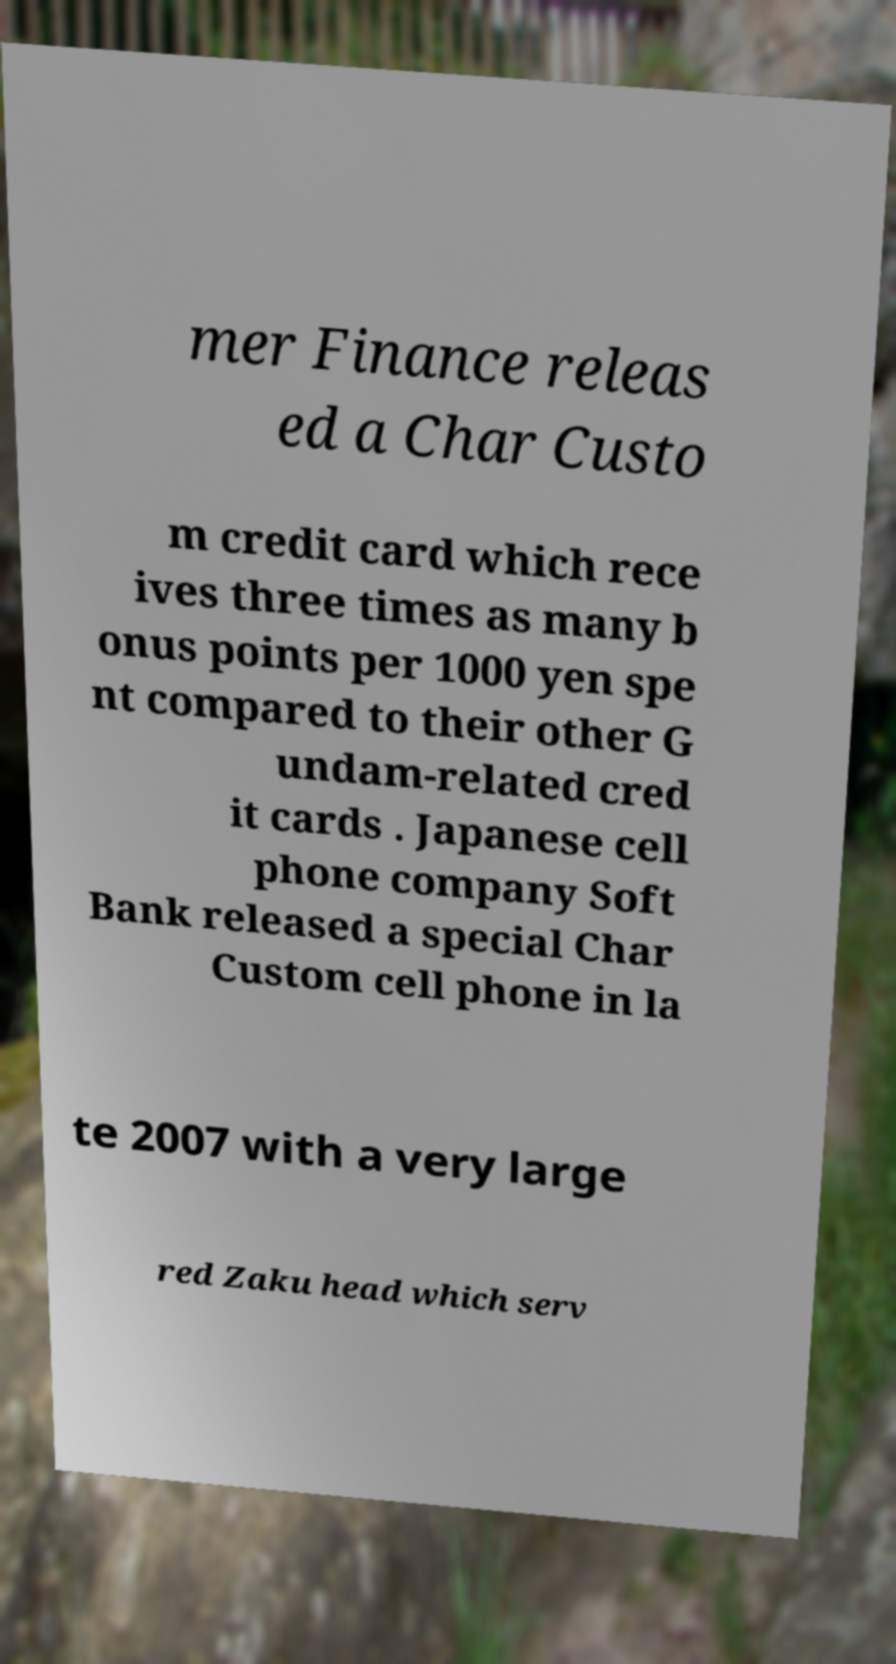Can you accurately transcribe the text from the provided image for me? mer Finance releas ed a Char Custo m credit card which rece ives three times as many b onus points per 1000 yen spe nt compared to their other G undam-related cred it cards . Japanese cell phone company Soft Bank released a special Char Custom cell phone in la te 2007 with a very large red Zaku head which serv 